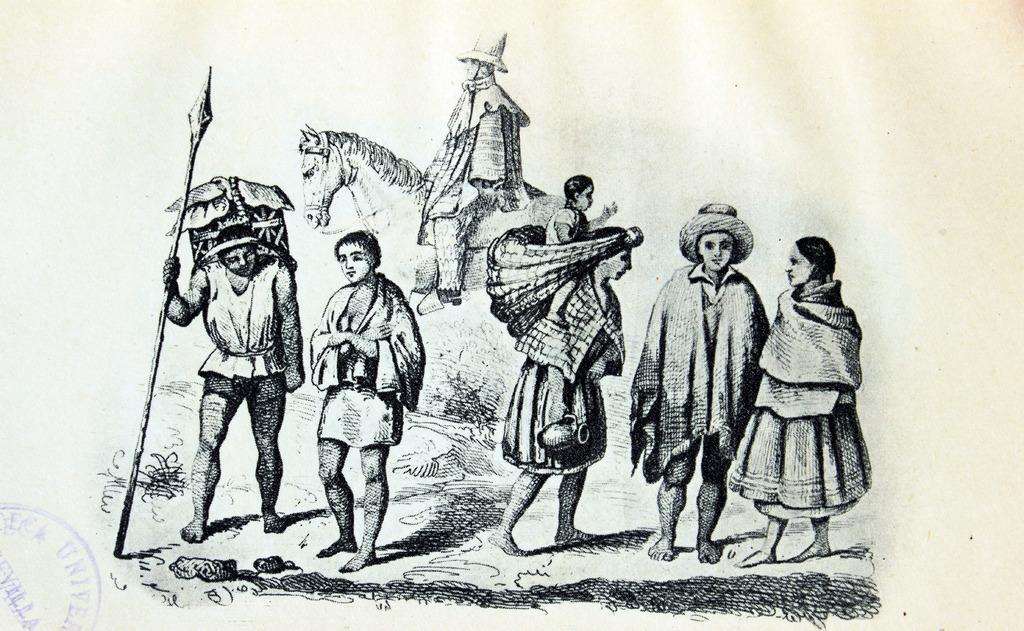What is the style of the image? The image appears to be a sketch. How many people are depicted in the sketch? There are seven persons in the sketch. What animal is present in the sketch? There is a horse in the sketch. What type of terrain is visible at the bottom of the sketch? Grass is present at the bottom of the sketch. What object is one of the men holding in the sketch? One of the men is holding a weapon in the sketch. Where is the cobweb located in the sketch? There is no cobweb present in the sketch. What shape is the ring that one of the characters is wearing in the sketch? There is no ring present in the sketch. 